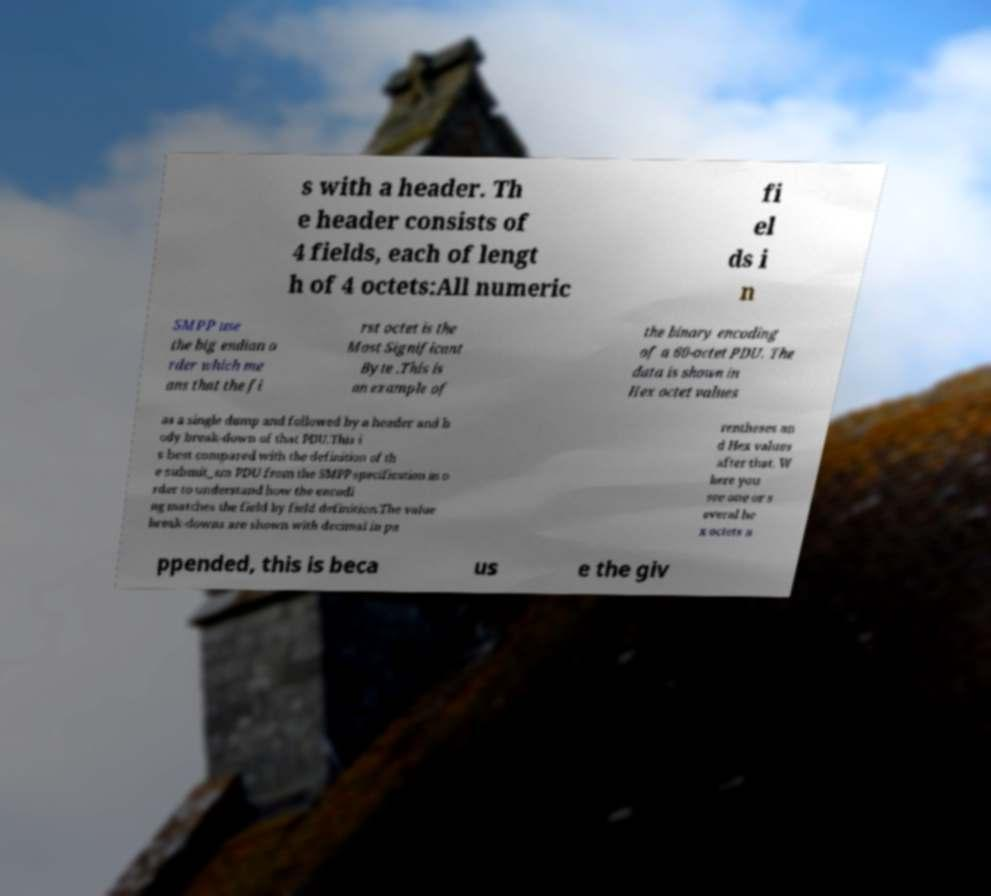Please identify and transcribe the text found in this image. s with a header. Th e header consists of 4 fields, each of lengt h of 4 octets:All numeric fi el ds i n SMPP use the big endian o rder which me ans that the fi rst octet is the Most Significant Byte .This is an example of the binary encoding of a 60-octet PDU. The data is shown in Hex octet values as a single dump and followed by a header and b ody break-down of that PDU.This i s best compared with the definition of th e submit_sm PDU from the SMPP specification in o rder to understand how the encodi ng matches the field by field definition.The value break-downs are shown with decimal in pa rentheses an d Hex values after that. W here you see one or s everal he x octets a ppended, this is beca us e the giv 